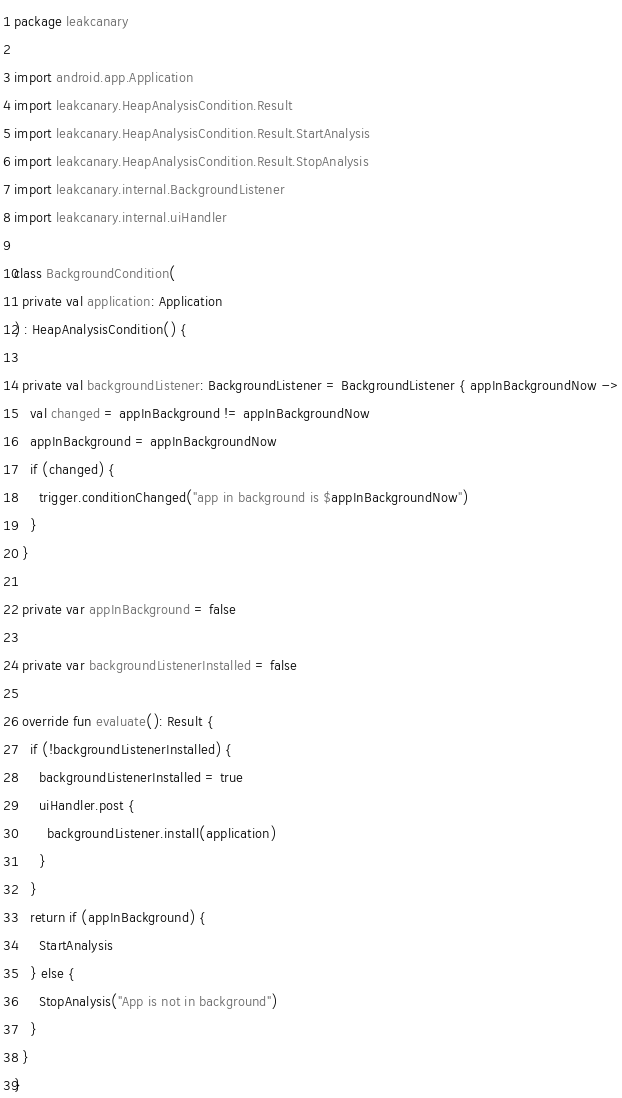Convert code to text. <code><loc_0><loc_0><loc_500><loc_500><_Kotlin_>package leakcanary

import android.app.Application
import leakcanary.HeapAnalysisCondition.Result
import leakcanary.HeapAnalysisCondition.Result.StartAnalysis
import leakcanary.HeapAnalysisCondition.Result.StopAnalysis
import leakcanary.internal.BackgroundListener
import leakcanary.internal.uiHandler

class BackgroundCondition(
  private val application: Application
) : HeapAnalysisCondition() {

  private val backgroundListener: BackgroundListener = BackgroundListener { appInBackgroundNow ->
    val changed = appInBackground != appInBackgroundNow
    appInBackground = appInBackgroundNow
    if (changed) {
      trigger.conditionChanged("app in background is $appInBackgroundNow")
    }
  }

  private var appInBackground = false

  private var backgroundListenerInstalled = false

  override fun evaluate(): Result {
    if (!backgroundListenerInstalled) {
      backgroundListenerInstalled = true
      uiHandler.post {
        backgroundListener.install(application)
      }
    }
    return if (appInBackground) {
      StartAnalysis
    } else {
      StopAnalysis("App is not in background")
    }
  }
}</code> 